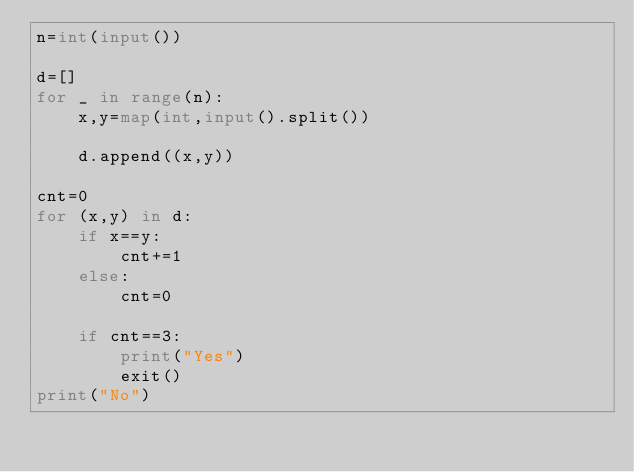Convert code to text. <code><loc_0><loc_0><loc_500><loc_500><_Python_>n=int(input())

d=[]
for _ in range(n):
    x,y=map(int,input().split())

    d.append((x,y))

cnt=0
for (x,y) in d:
    if x==y:
        cnt+=1
    else:
        cnt=0
    
    if cnt==3:
        print("Yes")
        exit()
print("No")
</code> 